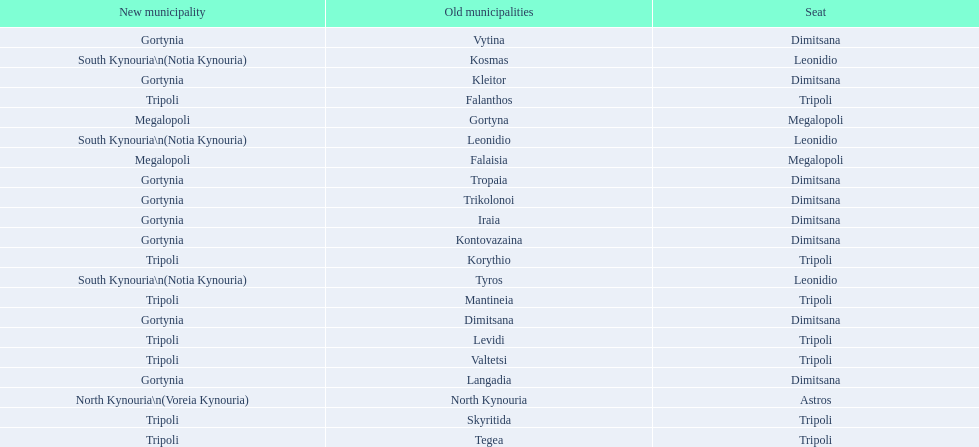Is tripoli still considered a municipality in arcadia since its 2011 reformation? Yes. 